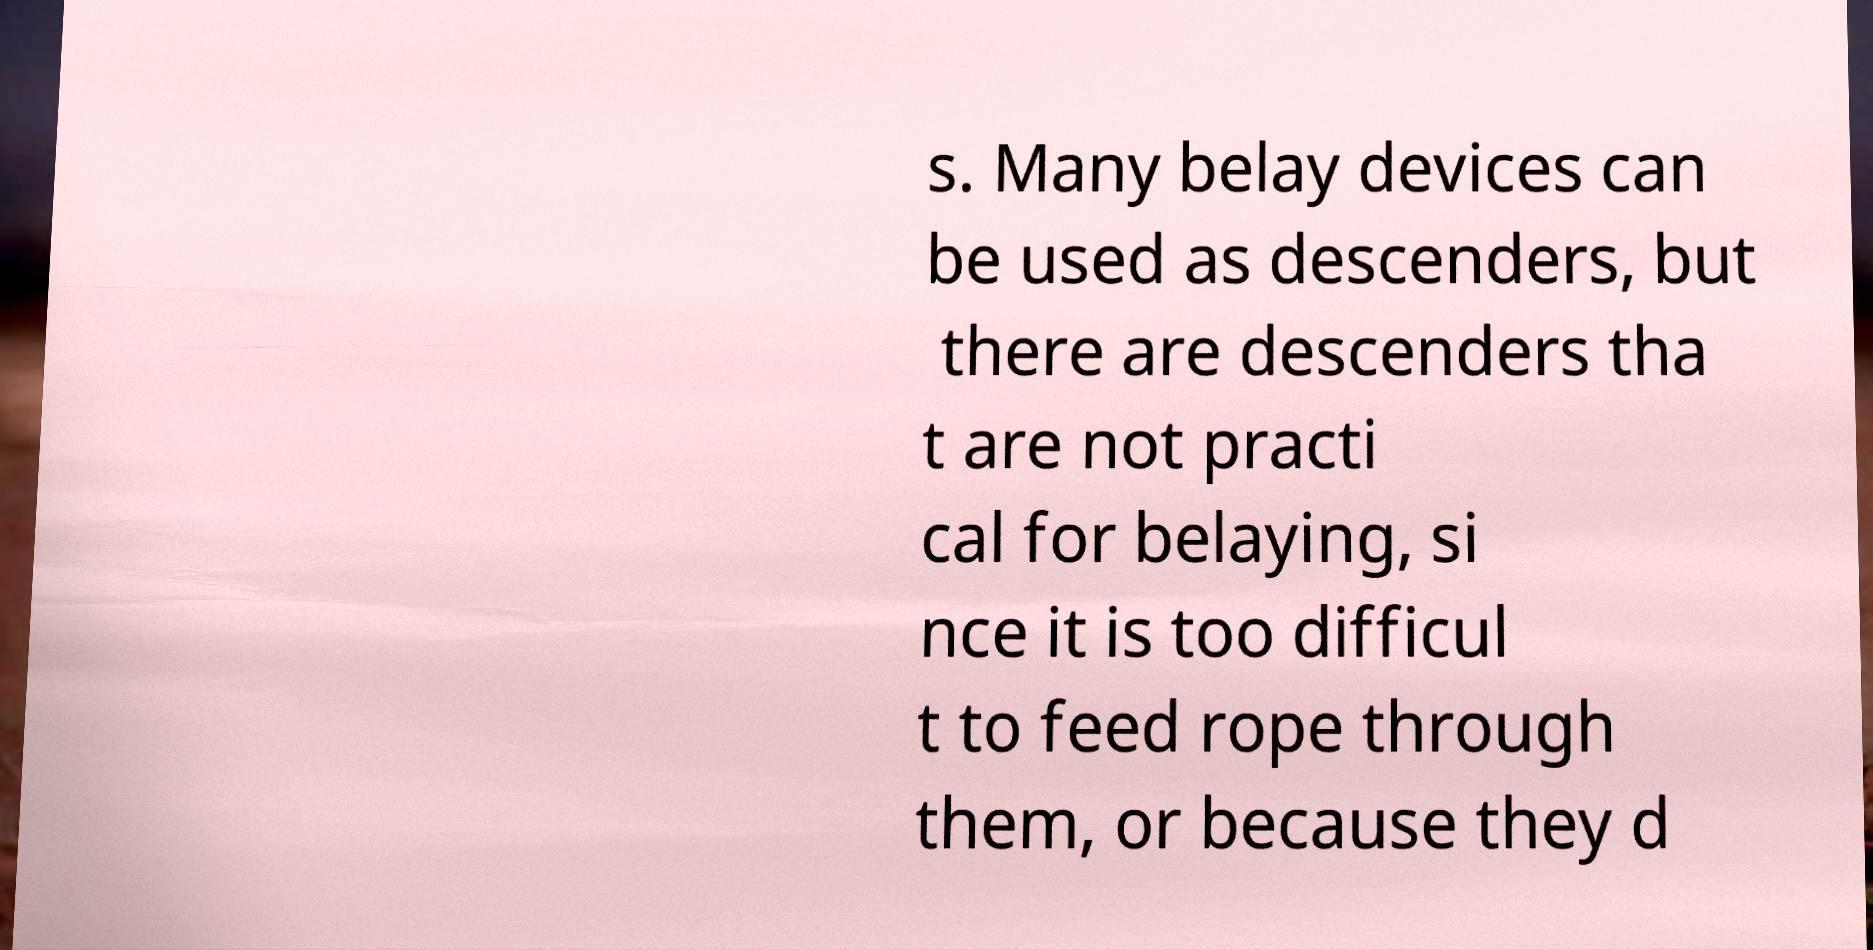There's text embedded in this image that I need extracted. Can you transcribe it verbatim? s. Many belay devices can be used as descenders, but there are descenders tha t are not practi cal for belaying, si nce it is too difficul t to feed rope through them, or because they d 